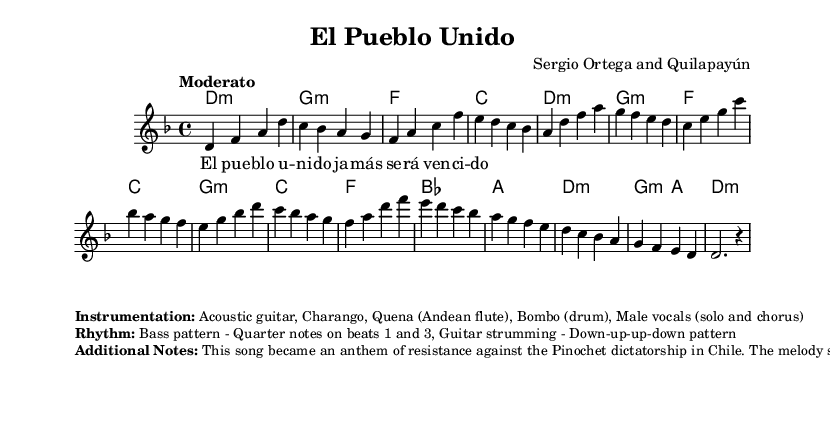What is the key signature of this music? The key signature is D minor, which is indicated by one flat (B flat). The music starts with the note D in the first measure, and since it is specified as being in D minor, we conclude that the key signature corresponds accordingly.
Answer: D minor What is the time signature of this music? The time signature is 4/4, as indicated at the beginning of the piece. This means there are four beats in each measure, and the quarter note gets one beat, which matches the consistent rhythm throughout the score.
Answer: 4/4 What is the tempo marking of the music? The tempo marking is "Moderato," which suggests a moderate pace. This information is given at the start of the score, providing an instruction for how quickly or slowly the piece should be played.
Answer: Moderato How many different chord changes are in the piece? There are 12 chord changes listed in the chord section of the score. By counting the chord symbols written above the staff, we determine that they appear in groups throughout the music, reflecting the structure of the accompaniment.
Answer: 12 What is the primary instrument used for the melody? The primary instrument for the melody is the voice, as indicated in the score where it exclusively shows a melody line with lyrics attached, suggesting vocal performance.
Answer: Voice What does the song symbolize in the context of its historical background? The song symbolizes resistance and unity against oppression, specifically referencing its role as an anthem during the Pinochet dictatorship in Chile. The lyrics and passionate music evoke a strong sense of collective struggle and hope.
Answer: Resistance 